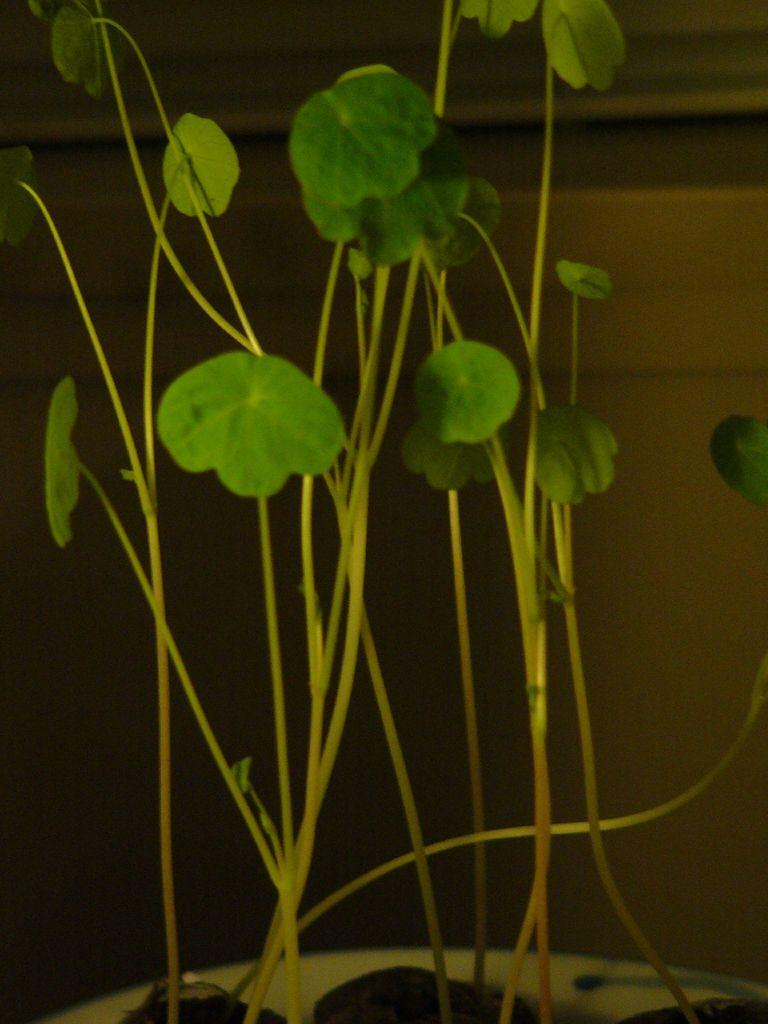What type of plant can be seen in the image? There is a houseplant in the image. What type of lace can be seen on the ship in the image? There is no ship or lace present in the image; it only features a houseplant. What sound does the whistle make in the image? There is no whistle present in the image. 